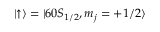Convert formula to latex. <formula><loc_0><loc_0><loc_500><loc_500>\left | \uparrow \right \rangle = | 6 0 S _ { 1 / 2 } , m _ { j } = + 1 / 2 \rangle</formula> 